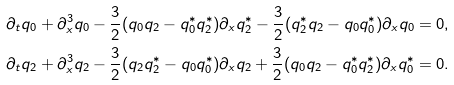Convert formula to latex. <formula><loc_0><loc_0><loc_500><loc_500>\partial _ { t } q _ { 0 } + \partial _ { x } ^ { 3 } q _ { 0 } - \frac { 3 } { 2 } ( q _ { 0 } q _ { 2 } - q ^ { * } _ { 0 } q ^ { * } _ { 2 } ) \partial _ { x } q ^ { * } _ { 2 } - \frac { 3 } { 2 } ( q ^ { * } _ { 2 } q _ { 2 } - q _ { 0 } q ^ { * } _ { 0 } ) \partial _ { x } q _ { 0 } = 0 , \\ \partial _ { t } q _ { 2 } + \partial _ { x } ^ { 3 } q _ { 2 } - \frac { 3 } { 2 } ( q _ { 2 } q ^ { * } _ { 2 } - q _ { 0 } q ^ { * } _ { 0 } ) \partial _ { x } q _ { 2 } + \frac { 3 } { 2 } ( q _ { 0 } q _ { 2 } - q ^ { * } _ { 0 } q ^ { * } _ { 2 } ) \partial _ { x } q ^ { * } _ { 0 } = 0 .</formula> 